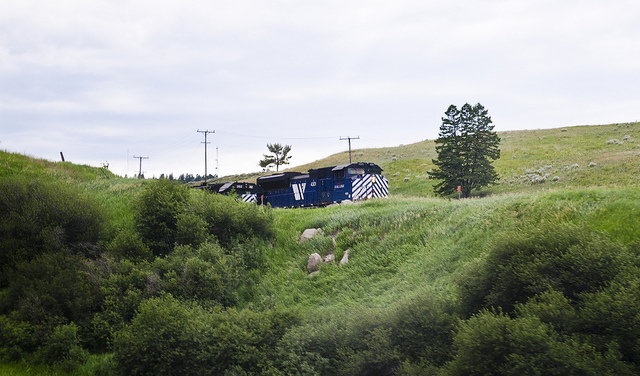Extract all visible text content from this image. W 